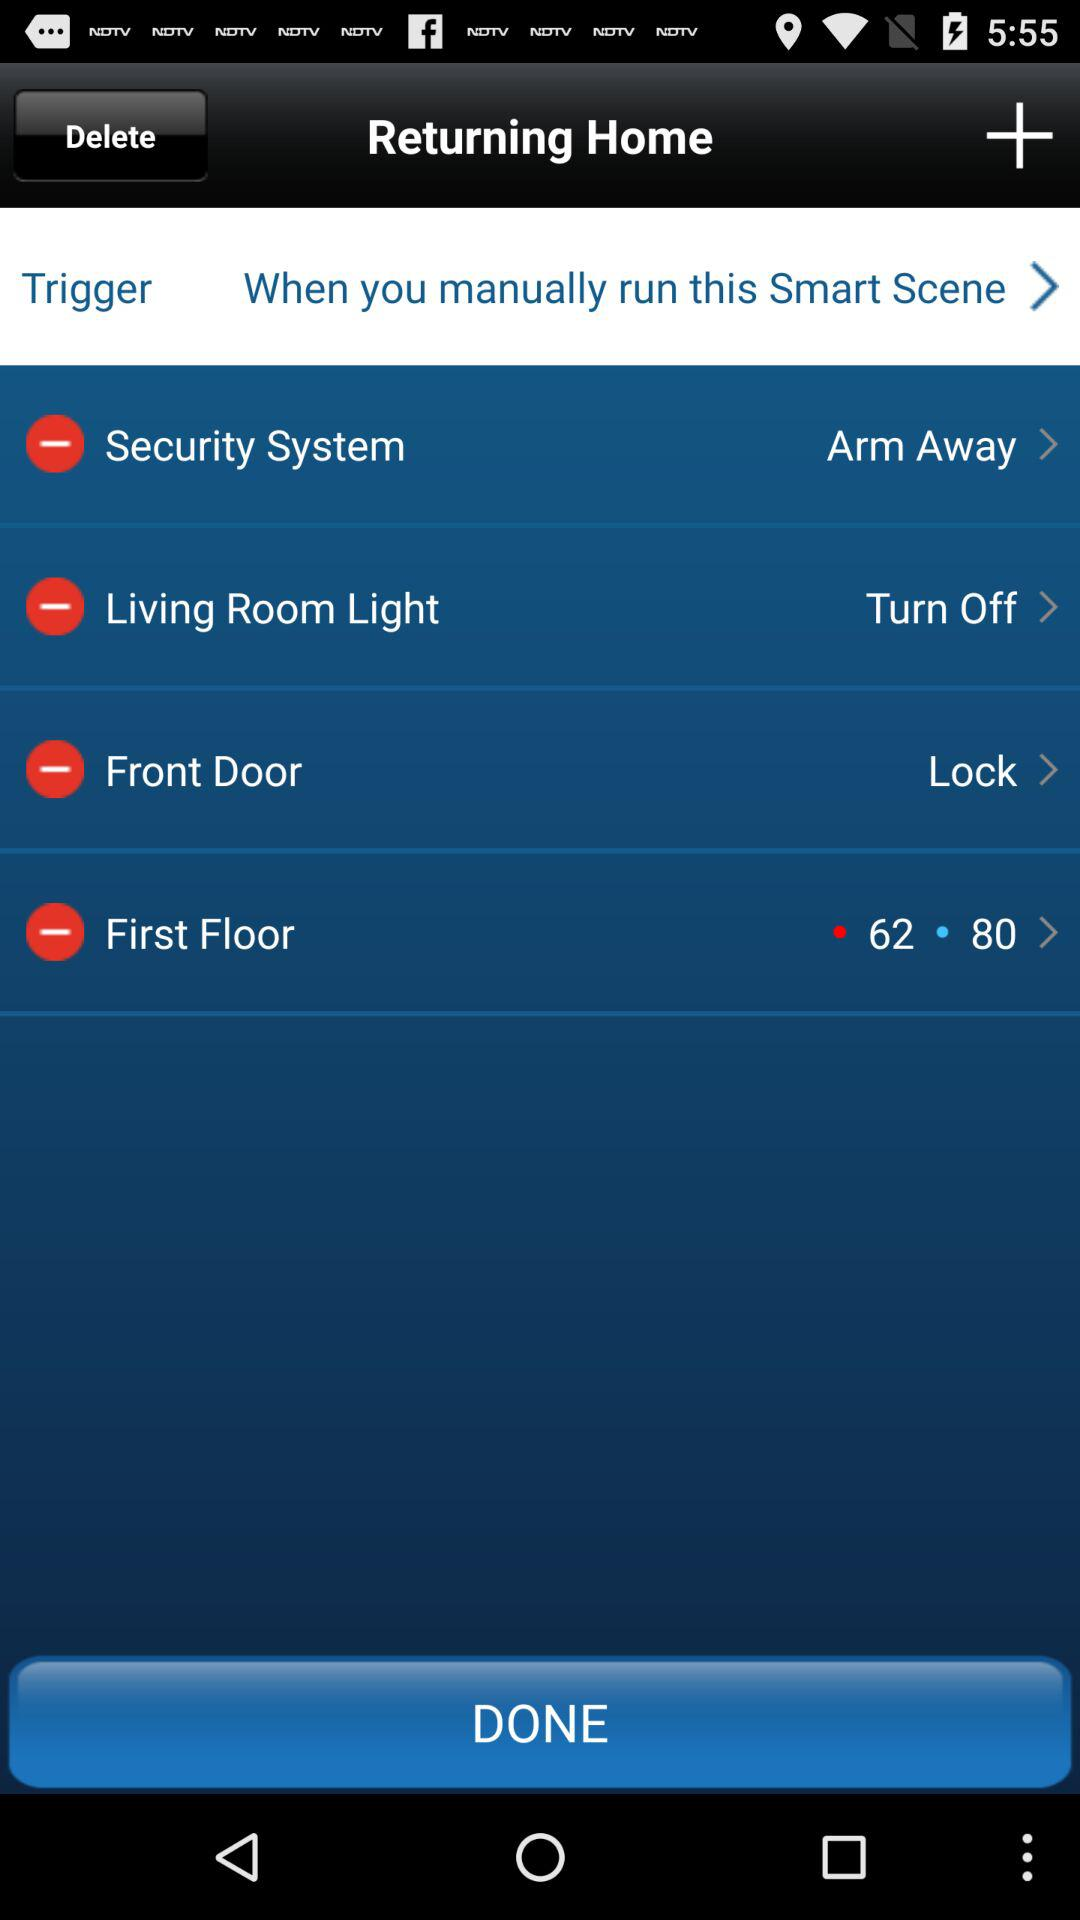What is the status of "Living Room Light"? The status is "Turn Off". 